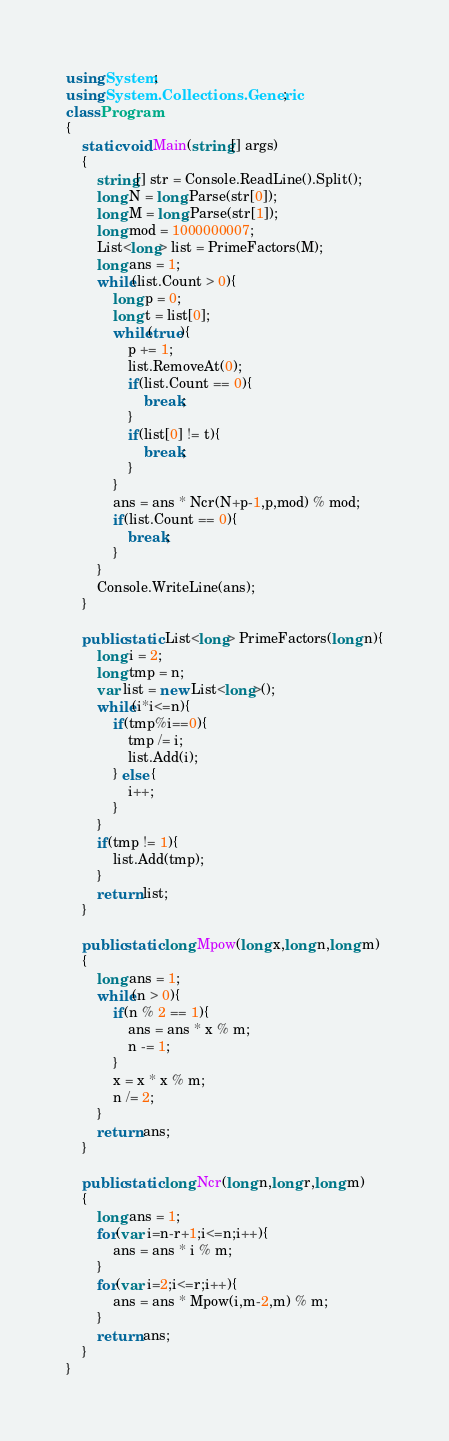Convert code to text. <code><loc_0><loc_0><loc_500><loc_500><_C#_>using System;
using System.Collections.Generic;
class Program
{
	static void Main(string[] args)
	{
		string[] str = Console.ReadLine().Split();
		long N = long.Parse(str[0]);
		long M = long.Parse(str[1]);
		long mod = 1000000007;
		List<long> list = PrimeFactors(M);
		long ans = 1;
		while(list.Count > 0){
			long p = 0;
			long t = list[0];
			while(true){
				p += 1;
				list.RemoveAt(0);
				if(list.Count == 0){
					break;
				}
				if(list[0] != t){
					break;
				}
			}
			ans = ans * Ncr(N+p-1,p,mod) % mod;
			if(list.Count == 0){
				break;
			}
		}
		Console.WriteLine(ans);
	}

	public static List<long> PrimeFactors(long n){
		long i = 2;
		long tmp = n;
		var list = new List<long>();
		while(i*i<=n){
			if(tmp%i==0){
				tmp /= i;
				list.Add(i);
			} else {
				i++;
			}
		}
		if(tmp != 1){
			list.Add(tmp);
		}
		return list;
	}

	public static long Mpow(long x,long n,long m)
	{
		long ans = 1;
		while(n > 0){
			if(n % 2 == 1){
				ans = ans * x % m;
				n -= 1;
			}
			x = x * x % m;
			n /= 2;
		}
		return ans;
	}

	public static long Ncr(long n,long r,long m)
	{
		long ans = 1;
		for(var i=n-r+1;i<=n;i++){
			ans = ans * i % m;
		}
		for(var i=2;i<=r;i++){
			ans = ans * Mpow(i,m-2,m) % m;
		}
		return ans;
	}
}</code> 